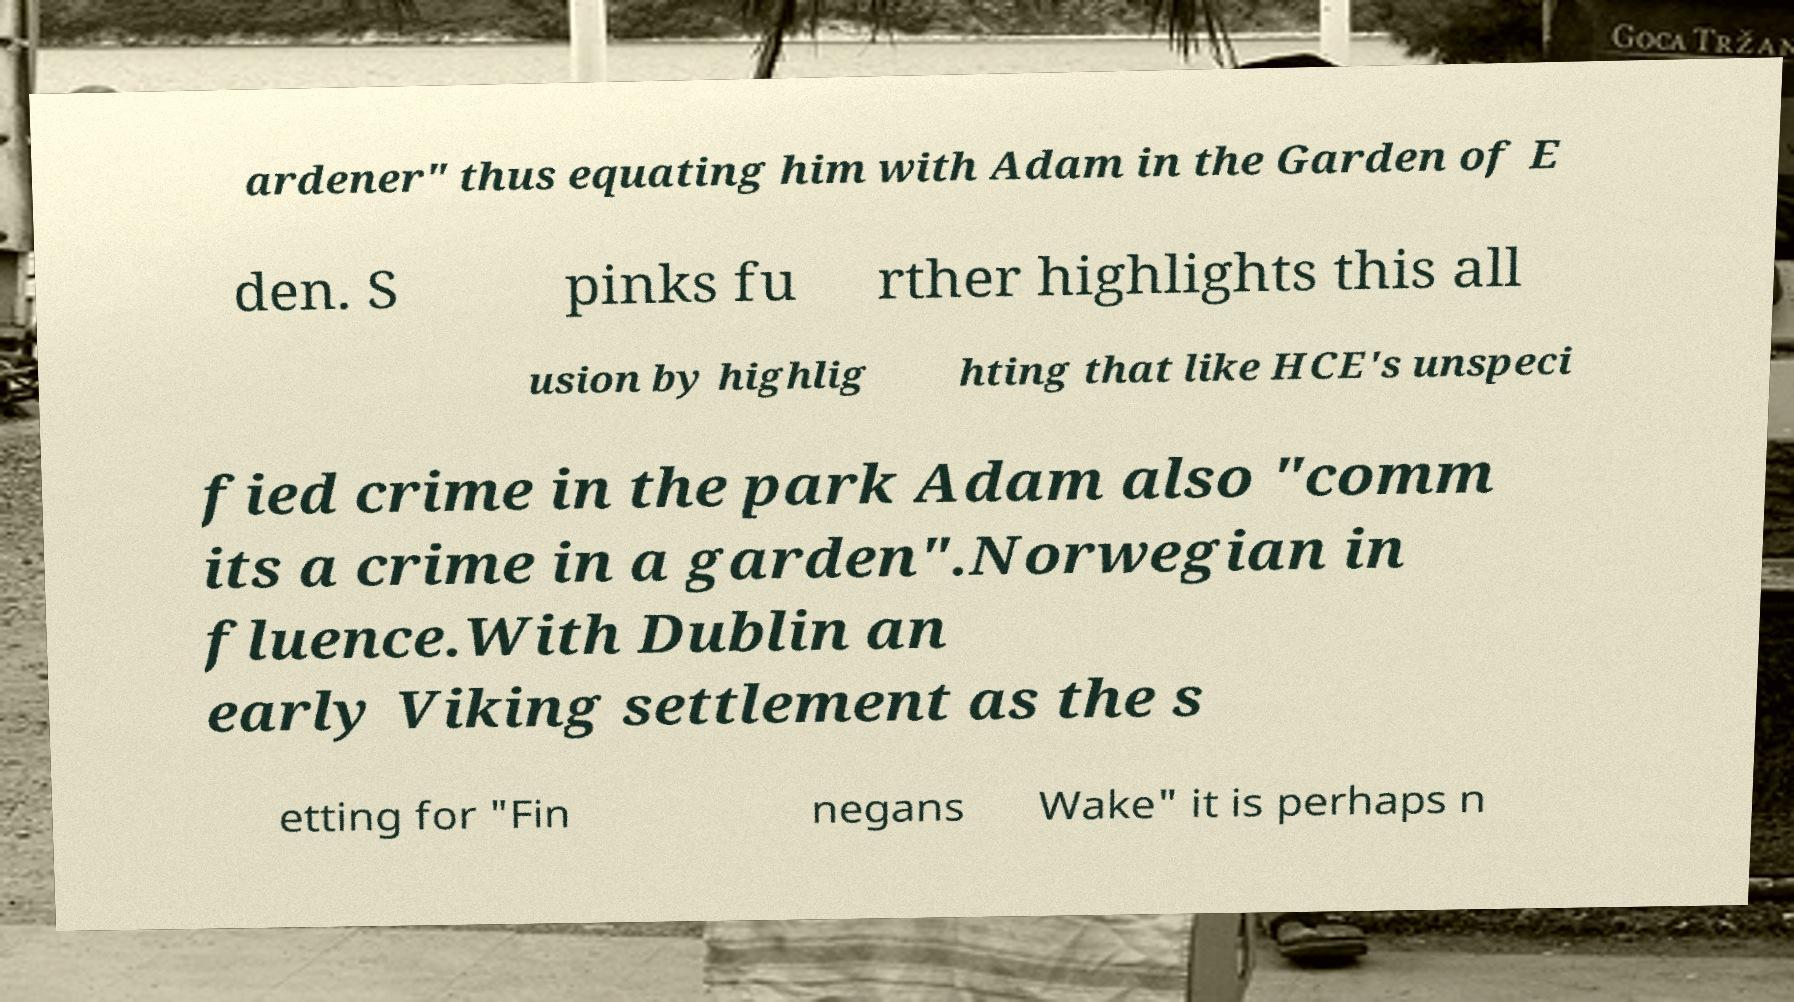Could you assist in decoding the text presented in this image and type it out clearly? ardener" thus equating him with Adam in the Garden of E den. S pinks fu rther highlights this all usion by highlig hting that like HCE's unspeci fied crime in the park Adam also "comm its a crime in a garden".Norwegian in fluence.With Dublin an early Viking settlement as the s etting for "Fin negans Wake" it is perhaps n 